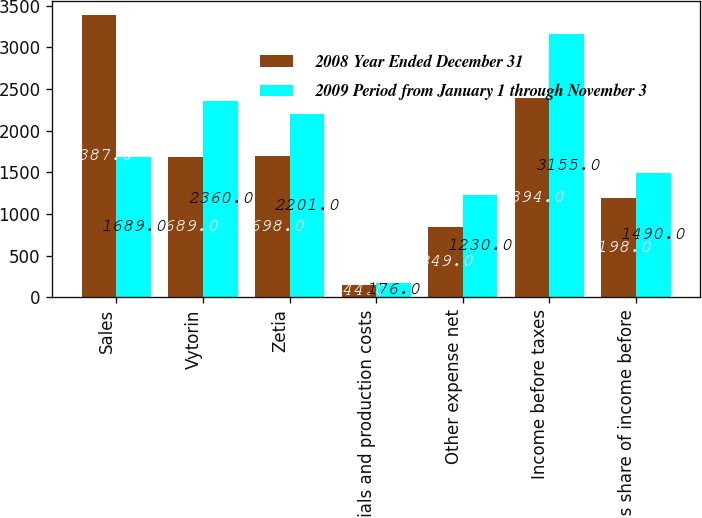<chart> <loc_0><loc_0><loc_500><loc_500><stacked_bar_chart><ecel><fcel>Sales<fcel>Vytorin<fcel>Zetia<fcel>Materials and production costs<fcel>Other expense net<fcel>Income before taxes<fcel>Merck's share of income before<nl><fcel>2008 Year Ended December 31<fcel>3387<fcel>1689<fcel>1698<fcel>144<fcel>849<fcel>2394<fcel>1198<nl><fcel>2009 Period from January 1 through November 3<fcel>1689<fcel>2360<fcel>2201<fcel>176<fcel>1230<fcel>3155<fcel>1490<nl></chart> 